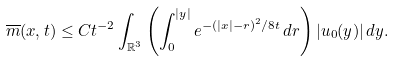<formula> <loc_0><loc_0><loc_500><loc_500>\overline { m } ( x , t ) \leq C t ^ { - 2 } \int _ { \mathbb { R } ^ { 3 } } \left ( \int _ { 0 } ^ { | y | } e ^ { - ( | x | - r ) ^ { 2 } / 8 t } \, d r \right ) | u _ { 0 } ( y ) | \, d y .</formula> 